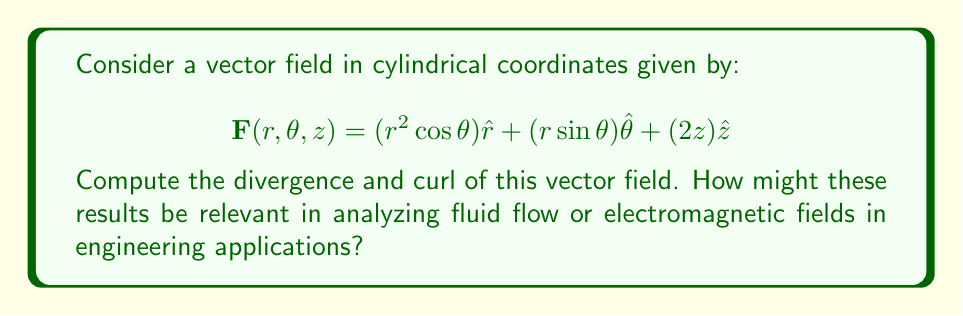What is the answer to this math problem? To compute the divergence and curl of the given vector field in cylindrical coordinates, we'll use the following formulas:

1. Divergence in cylindrical coordinates:
   $$\text{div}\mathbf{F} = \nabla \cdot \mathbf{F} = \frac{1}{r}\frac{\partial}{\partial r}(rF_r) + \frac{1}{r}\frac{\partial F_\theta}{\partial \theta} + \frac{\partial F_z}{\partial z}$$

2. Curl in cylindrical coordinates:
   $$\text{curl}\mathbf{F} = \nabla \times \mathbf{F} = \left(\frac{1}{r}\frac{\partial F_z}{\partial \theta} - \frac{\partial F_\theta}{\partial z}\right)\hat{r} + \left(\frac{\partial F_r}{\partial z} - \frac{\partial F_z}{\partial r}\right)\hat{\theta} + \frac{1}{r}\left(\frac{\partial}{\partial r}(rF_\theta) - \frac{\partial F_r}{\partial \theta}\right)\hat{z}$$

Let's break this down step-by-step:

Step 1: Identify the components of the vector field
$F_r = r^2 \cos\theta$
$F_\theta = r \sin\theta$
$F_z = 2z$

Step 2: Calculate the divergence

$$\begin{align*}
\text{div}\mathbf{F} &= \frac{1}{r}\frac{\partial}{\partial r}(rF_r) + \frac{1}{r}\frac{\partial F_\theta}{\partial \theta} + \frac{\partial F_z}{\partial z} \\
&= \frac{1}{r}\frac{\partial}{\partial r}(r \cdot r^2 \cos\theta) + \frac{1}{r}\frac{\partial}{\partial \theta}(r \sin\theta) + \frac{\partial}{\partial z}(2z) \\
&= \frac{1}{r}\frac{\partial}{\partial r}(r^3 \cos\theta) + \frac{1}{r}(r \cos\theta) + 2 \\
&= \frac{1}{r}(3r^2 \cos\theta) + \cos\theta + 2 \\
&= 3r \cos\theta + \cos\theta + 2 \\
&= (3r + 1)\cos\theta + 2
\end{align*}$$

Step 3: Calculate the curl

For $\hat{r}$ component:
$$\begin{align*}
\frac{1}{r}\frac{\partial F_z}{\partial \theta} - \frac{\partial F_\theta}{\partial z} &= \frac{1}{r}\frac{\partial}{\partial \theta}(2z) - \frac{\partial}{\partial z}(r \sin\theta) \\
&= 0 - 0 = 0
\end{align*}$$

For $\hat{\theta}$ component:
$$\begin{align*}
\frac{\partial F_r}{\partial z} - \frac{\partial F_z}{\partial r} &= \frac{\partial}{\partial z}(r^2 \cos\theta) - \frac{\partial}{\partial r}(2z) \\
&= 0 - 0 = 0
\end{align*}$$

For $\hat{z}$ component:
$$\begin{align*}
\frac{1}{r}\left(\frac{\partial}{\partial r}(rF_\theta) - \frac{\partial F_r}{\partial \theta}\right) &= \frac{1}{r}\left(\frac{\partial}{\partial r}(r^2 \sin\theta) - \frac{\partial}{\partial \theta}(r^2 \cos\theta)\right) \\
&= \frac{1}{r}(2r \sin\theta + r^2 \sin\theta) \\
&= 2 \sin\theta + r \sin\theta
\end{align*}$$

Therefore, the curl is:
$$\text{curl}\mathbf{F} = (2 \sin\theta + r \sin\theta)\hat{z}$$

These results are relevant in engineering applications such as:

1. Fluid dynamics: The divergence can indicate sources or sinks in a fluid flow, while the curl can represent rotational motion or vorticity.
2. Electromagnetics: In Maxwell's equations, the divergence of the electric field is related to charge density, while the curl of the magnetic field is related to current density and the time derivative of the electric field.
3. Heat transfer: The divergence can represent heat sources or sinks in a material.
Answer: Divergence: $\text{div}\mathbf{F} = (3r + 1)\cos\theta + 2$

Curl: $\text{curl}\mathbf{F} = (2 \sin\theta + r \sin\theta)\hat{z}$ 